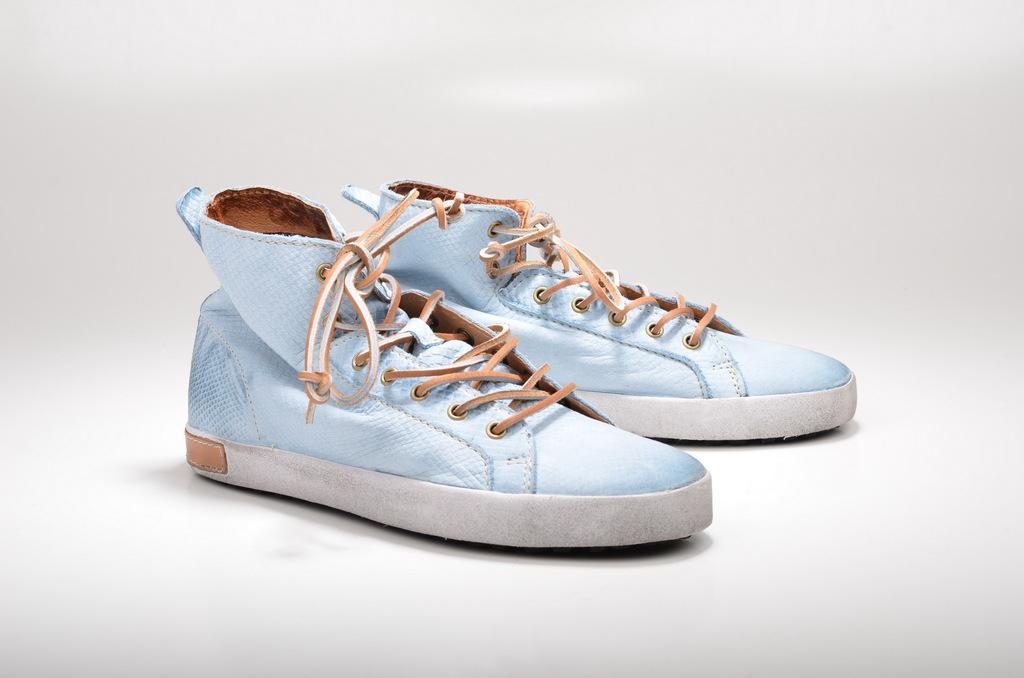Can you describe this image briefly? In the image we can see there are shoes kept on the table. 